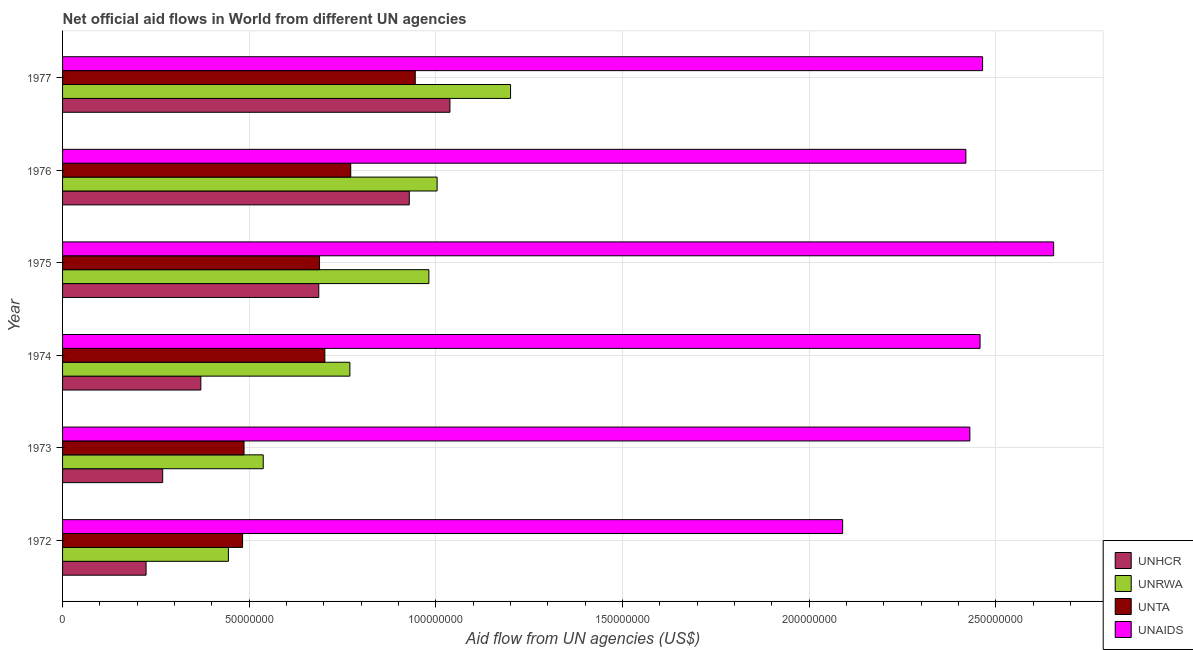How many different coloured bars are there?
Provide a short and direct response. 4. How many groups of bars are there?
Give a very brief answer. 6. Are the number of bars on each tick of the Y-axis equal?
Ensure brevity in your answer.  Yes. What is the label of the 2nd group of bars from the top?
Offer a very short reply. 1976. In how many cases, is the number of bars for a given year not equal to the number of legend labels?
Provide a succinct answer. 0. What is the amount of aid given by unaids in 1975?
Your answer should be very brief. 2.65e+08. Across all years, what is the maximum amount of aid given by unaids?
Make the answer very short. 2.65e+08. Across all years, what is the minimum amount of aid given by unrwa?
Provide a succinct answer. 4.44e+07. In which year was the amount of aid given by unaids maximum?
Ensure brevity in your answer.  1975. What is the total amount of aid given by unhcr in the graph?
Provide a succinct answer. 3.51e+08. What is the difference between the amount of aid given by unta in 1972 and that in 1976?
Make the answer very short. -2.90e+07. What is the difference between the amount of aid given by unrwa in 1972 and the amount of aid given by unaids in 1975?
Ensure brevity in your answer.  -2.21e+08. What is the average amount of aid given by unhcr per year?
Make the answer very short. 5.86e+07. In the year 1977, what is the difference between the amount of aid given by unrwa and amount of aid given by unaids?
Ensure brevity in your answer.  -1.26e+08. In how many years, is the amount of aid given by unta greater than 40000000 US$?
Provide a short and direct response. 6. What is the ratio of the amount of aid given by unhcr in 1973 to that in 1974?
Your answer should be compact. 0.72. What is the difference between the highest and the second highest amount of aid given by unrwa?
Offer a very short reply. 1.97e+07. What is the difference between the highest and the lowest amount of aid given by unhcr?
Provide a succinct answer. 8.14e+07. In how many years, is the amount of aid given by unhcr greater than the average amount of aid given by unhcr taken over all years?
Give a very brief answer. 3. What does the 2nd bar from the top in 1974 represents?
Provide a succinct answer. UNTA. What does the 3rd bar from the bottom in 1976 represents?
Ensure brevity in your answer.  UNTA. Is it the case that in every year, the sum of the amount of aid given by unhcr and amount of aid given by unrwa is greater than the amount of aid given by unta?
Provide a short and direct response. Yes. How many years are there in the graph?
Your answer should be very brief. 6. Does the graph contain grids?
Give a very brief answer. Yes. How many legend labels are there?
Make the answer very short. 4. How are the legend labels stacked?
Your response must be concise. Vertical. What is the title of the graph?
Provide a short and direct response. Net official aid flows in World from different UN agencies. Does "Manufacturing" appear as one of the legend labels in the graph?
Provide a short and direct response. No. What is the label or title of the X-axis?
Your answer should be compact. Aid flow from UN agencies (US$). What is the Aid flow from UN agencies (US$) of UNHCR in 1972?
Make the answer very short. 2.24e+07. What is the Aid flow from UN agencies (US$) of UNRWA in 1972?
Your response must be concise. 4.44e+07. What is the Aid flow from UN agencies (US$) in UNTA in 1972?
Provide a short and direct response. 4.82e+07. What is the Aid flow from UN agencies (US$) in UNAIDS in 1972?
Provide a succinct answer. 2.09e+08. What is the Aid flow from UN agencies (US$) in UNHCR in 1973?
Make the answer very short. 2.68e+07. What is the Aid flow from UN agencies (US$) in UNRWA in 1973?
Give a very brief answer. 5.38e+07. What is the Aid flow from UN agencies (US$) in UNTA in 1973?
Keep it short and to the point. 4.86e+07. What is the Aid flow from UN agencies (US$) in UNAIDS in 1973?
Your response must be concise. 2.43e+08. What is the Aid flow from UN agencies (US$) of UNHCR in 1974?
Your response must be concise. 3.70e+07. What is the Aid flow from UN agencies (US$) of UNRWA in 1974?
Offer a terse response. 7.70e+07. What is the Aid flow from UN agencies (US$) of UNTA in 1974?
Offer a terse response. 7.03e+07. What is the Aid flow from UN agencies (US$) of UNAIDS in 1974?
Your response must be concise. 2.46e+08. What is the Aid flow from UN agencies (US$) of UNHCR in 1975?
Keep it short and to the point. 6.86e+07. What is the Aid flow from UN agencies (US$) in UNRWA in 1975?
Give a very brief answer. 9.81e+07. What is the Aid flow from UN agencies (US$) in UNTA in 1975?
Your answer should be very brief. 6.88e+07. What is the Aid flow from UN agencies (US$) of UNAIDS in 1975?
Keep it short and to the point. 2.65e+08. What is the Aid flow from UN agencies (US$) in UNHCR in 1976?
Offer a very short reply. 9.29e+07. What is the Aid flow from UN agencies (US$) of UNRWA in 1976?
Provide a short and direct response. 1.00e+08. What is the Aid flow from UN agencies (US$) in UNTA in 1976?
Ensure brevity in your answer.  7.72e+07. What is the Aid flow from UN agencies (US$) in UNAIDS in 1976?
Your response must be concise. 2.42e+08. What is the Aid flow from UN agencies (US$) in UNHCR in 1977?
Ensure brevity in your answer.  1.04e+08. What is the Aid flow from UN agencies (US$) in UNRWA in 1977?
Provide a succinct answer. 1.20e+08. What is the Aid flow from UN agencies (US$) in UNTA in 1977?
Provide a succinct answer. 9.45e+07. What is the Aid flow from UN agencies (US$) of UNAIDS in 1977?
Give a very brief answer. 2.46e+08. Across all years, what is the maximum Aid flow from UN agencies (US$) of UNHCR?
Offer a very short reply. 1.04e+08. Across all years, what is the maximum Aid flow from UN agencies (US$) of UNRWA?
Your response must be concise. 1.20e+08. Across all years, what is the maximum Aid flow from UN agencies (US$) of UNTA?
Provide a short and direct response. 9.45e+07. Across all years, what is the maximum Aid flow from UN agencies (US$) in UNAIDS?
Make the answer very short. 2.65e+08. Across all years, what is the minimum Aid flow from UN agencies (US$) in UNHCR?
Offer a terse response. 2.24e+07. Across all years, what is the minimum Aid flow from UN agencies (US$) in UNRWA?
Your response must be concise. 4.44e+07. Across all years, what is the minimum Aid flow from UN agencies (US$) in UNTA?
Offer a very short reply. 4.82e+07. Across all years, what is the minimum Aid flow from UN agencies (US$) of UNAIDS?
Give a very brief answer. 2.09e+08. What is the total Aid flow from UN agencies (US$) of UNHCR in the graph?
Your answer should be very brief. 3.51e+08. What is the total Aid flow from UN agencies (US$) of UNRWA in the graph?
Your response must be concise. 4.94e+08. What is the total Aid flow from UN agencies (US$) in UNTA in the graph?
Keep it short and to the point. 4.08e+08. What is the total Aid flow from UN agencies (US$) in UNAIDS in the graph?
Ensure brevity in your answer.  1.45e+09. What is the difference between the Aid flow from UN agencies (US$) in UNHCR in 1972 and that in 1973?
Keep it short and to the point. -4.45e+06. What is the difference between the Aid flow from UN agencies (US$) of UNRWA in 1972 and that in 1973?
Provide a short and direct response. -9.33e+06. What is the difference between the Aid flow from UN agencies (US$) in UNTA in 1972 and that in 1973?
Your answer should be very brief. -3.90e+05. What is the difference between the Aid flow from UN agencies (US$) of UNAIDS in 1972 and that in 1973?
Offer a very short reply. -3.41e+07. What is the difference between the Aid flow from UN agencies (US$) in UNHCR in 1972 and that in 1974?
Give a very brief answer. -1.47e+07. What is the difference between the Aid flow from UN agencies (US$) in UNRWA in 1972 and that in 1974?
Give a very brief answer. -3.25e+07. What is the difference between the Aid flow from UN agencies (US$) in UNTA in 1972 and that in 1974?
Offer a terse response. -2.20e+07. What is the difference between the Aid flow from UN agencies (US$) in UNAIDS in 1972 and that in 1974?
Your answer should be very brief. -3.68e+07. What is the difference between the Aid flow from UN agencies (US$) in UNHCR in 1972 and that in 1975?
Offer a terse response. -4.63e+07. What is the difference between the Aid flow from UN agencies (US$) of UNRWA in 1972 and that in 1975?
Offer a terse response. -5.37e+07. What is the difference between the Aid flow from UN agencies (US$) of UNTA in 1972 and that in 1975?
Your response must be concise. -2.06e+07. What is the difference between the Aid flow from UN agencies (US$) of UNAIDS in 1972 and that in 1975?
Your response must be concise. -5.65e+07. What is the difference between the Aid flow from UN agencies (US$) in UNHCR in 1972 and that in 1976?
Provide a short and direct response. -7.05e+07. What is the difference between the Aid flow from UN agencies (US$) in UNRWA in 1972 and that in 1976?
Offer a very short reply. -5.59e+07. What is the difference between the Aid flow from UN agencies (US$) in UNTA in 1972 and that in 1976?
Provide a short and direct response. -2.90e+07. What is the difference between the Aid flow from UN agencies (US$) in UNAIDS in 1972 and that in 1976?
Make the answer very short. -3.30e+07. What is the difference between the Aid flow from UN agencies (US$) in UNHCR in 1972 and that in 1977?
Make the answer very short. -8.14e+07. What is the difference between the Aid flow from UN agencies (US$) in UNRWA in 1972 and that in 1977?
Give a very brief answer. -7.56e+07. What is the difference between the Aid flow from UN agencies (US$) in UNTA in 1972 and that in 1977?
Your answer should be very brief. -4.62e+07. What is the difference between the Aid flow from UN agencies (US$) in UNAIDS in 1972 and that in 1977?
Give a very brief answer. -3.75e+07. What is the difference between the Aid flow from UN agencies (US$) in UNHCR in 1973 and that in 1974?
Your answer should be very brief. -1.02e+07. What is the difference between the Aid flow from UN agencies (US$) of UNRWA in 1973 and that in 1974?
Provide a short and direct response. -2.32e+07. What is the difference between the Aid flow from UN agencies (US$) in UNTA in 1973 and that in 1974?
Keep it short and to the point. -2.16e+07. What is the difference between the Aid flow from UN agencies (US$) in UNAIDS in 1973 and that in 1974?
Give a very brief answer. -2.73e+06. What is the difference between the Aid flow from UN agencies (US$) in UNHCR in 1973 and that in 1975?
Keep it short and to the point. -4.18e+07. What is the difference between the Aid flow from UN agencies (US$) of UNRWA in 1973 and that in 1975?
Provide a succinct answer. -4.44e+07. What is the difference between the Aid flow from UN agencies (US$) of UNTA in 1973 and that in 1975?
Provide a short and direct response. -2.02e+07. What is the difference between the Aid flow from UN agencies (US$) of UNAIDS in 1973 and that in 1975?
Make the answer very short. -2.24e+07. What is the difference between the Aid flow from UN agencies (US$) of UNHCR in 1973 and that in 1976?
Provide a short and direct response. -6.60e+07. What is the difference between the Aid flow from UN agencies (US$) of UNRWA in 1973 and that in 1976?
Provide a short and direct response. -4.66e+07. What is the difference between the Aid flow from UN agencies (US$) of UNTA in 1973 and that in 1976?
Provide a short and direct response. -2.86e+07. What is the difference between the Aid flow from UN agencies (US$) in UNAIDS in 1973 and that in 1976?
Provide a succinct answer. 1.06e+06. What is the difference between the Aid flow from UN agencies (US$) of UNHCR in 1973 and that in 1977?
Provide a short and direct response. -7.69e+07. What is the difference between the Aid flow from UN agencies (US$) in UNRWA in 1973 and that in 1977?
Offer a very short reply. -6.62e+07. What is the difference between the Aid flow from UN agencies (US$) of UNTA in 1973 and that in 1977?
Your response must be concise. -4.59e+07. What is the difference between the Aid flow from UN agencies (US$) of UNAIDS in 1973 and that in 1977?
Provide a short and direct response. -3.41e+06. What is the difference between the Aid flow from UN agencies (US$) of UNHCR in 1974 and that in 1975?
Your answer should be compact. -3.16e+07. What is the difference between the Aid flow from UN agencies (US$) in UNRWA in 1974 and that in 1975?
Ensure brevity in your answer.  -2.12e+07. What is the difference between the Aid flow from UN agencies (US$) of UNTA in 1974 and that in 1975?
Ensure brevity in your answer.  1.43e+06. What is the difference between the Aid flow from UN agencies (US$) of UNAIDS in 1974 and that in 1975?
Make the answer very short. -1.97e+07. What is the difference between the Aid flow from UN agencies (US$) in UNHCR in 1974 and that in 1976?
Your answer should be compact. -5.58e+07. What is the difference between the Aid flow from UN agencies (US$) of UNRWA in 1974 and that in 1976?
Offer a terse response. -2.34e+07. What is the difference between the Aid flow from UN agencies (US$) of UNTA in 1974 and that in 1976?
Ensure brevity in your answer.  -6.93e+06. What is the difference between the Aid flow from UN agencies (US$) in UNAIDS in 1974 and that in 1976?
Offer a terse response. 3.79e+06. What is the difference between the Aid flow from UN agencies (US$) of UNHCR in 1974 and that in 1977?
Offer a very short reply. -6.67e+07. What is the difference between the Aid flow from UN agencies (US$) of UNRWA in 1974 and that in 1977?
Ensure brevity in your answer.  -4.30e+07. What is the difference between the Aid flow from UN agencies (US$) of UNTA in 1974 and that in 1977?
Your response must be concise. -2.42e+07. What is the difference between the Aid flow from UN agencies (US$) of UNAIDS in 1974 and that in 1977?
Offer a terse response. -6.80e+05. What is the difference between the Aid flow from UN agencies (US$) in UNHCR in 1975 and that in 1976?
Make the answer very short. -2.42e+07. What is the difference between the Aid flow from UN agencies (US$) of UNRWA in 1975 and that in 1976?
Offer a terse response. -2.20e+06. What is the difference between the Aid flow from UN agencies (US$) in UNTA in 1975 and that in 1976?
Provide a succinct answer. -8.36e+06. What is the difference between the Aid flow from UN agencies (US$) in UNAIDS in 1975 and that in 1976?
Offer a very short reply. 2.35e+07. What is the difference between the Aid flow from UN agencies (US$) in UNHCR in 1975 and that in 1977?
Provide a short and direct response. -3.51e+07. What is the difference between the Aid flow from UN agencies (US$) of UNRWA in 1975 and that in 1977?
Make the answer very short. -2.19e+07. What is the difference between the Aid flow from UN agencies (US$) of UNTA in 1975 and that in 1977?
Your answer should be very brief. -2.56e+07. What is the difference between the Aid flow from UN agencies (US$) in UNAIDS in 1975 and that in 1977?
Give a very brief answer. 1.90e+07. What is the difference between the Aid flow from UN agencies (US$) in UNHCR in 1976 and that in 1977?
Provide a succinct answer. -1.09e+07. What is the difference between the Aid flow from UN agencies (US$) of UNRWA in 1976 and that in 1977?
Your answer should be very brief. -1.97e+07. What is the difference between the Aid flow from UN agencies (US$) of UNTA in 1976 and that in 1977?
Offer a terse response. -1.73e+07. What is the difference between the Aid flow from UN agencies (US$) of UNAIDS in 1976 and that in 1977?
Offer a terse response. -4.47e+06. What is the difference between the Aid flow from UN agencies (US$) in UNHCR in 1972 and the Aid flow from UN agencies (US$) in UNRWA in 1973?
Keep it short and to the point. -3.14e+07. What is the difference between the Aid flow from UN agencies (US$) of UNHCR in 1972 and the Aid flow from UN agencies (US$) of UNTA in 1973?
Provide a short and direct response. -2.62e+07. What is the difference between the Aid flow from UN agencies (US$) in UNHCR in 1972 and the Aid flow from UN agencies (US$) in UNAIDS in 1973?
Give a very brief answer. -2.21e+08. What is the difference between the Aid flow from UN agencies (US$) in UNRWA in 1972 and the Aid flow from UN agencies (US$) in UNTA in 1973?
Keep it short and to the point. -4.19e+06. What is the difference between the Aid flow from UN agencies (US$) of UNRWA in 1972 and the Aid flow from UN agencies (US$) of UNAIDS in 1973?
Offer a terse response. -1.99e+08. What is the difference between the Aid flow from UN agencies (US$) of UNTA in 1972 and the Aid flow from UN agencies (US$) of UNAIDS in 1973?
Offer a very short reply. -1.95e+08. What is the difference between the Aid flow from UN agencies (US$) of UNHCR in 1972 and the Aid flow from UN agencies (US$) of UNRWA in 1974?
Provide a short and direct response. -5.46e+07. What is the difference between the Aid flow from UN agencies (US$) of UNHCR in 1972 and the Aid flow from UN agencies (US$) of UNTA in 1974?
Your response must be concise. -4.79e+07. What is the difference between the Aid flow from UN agencies (US$) in UNHCR in 1972 and the Aid flow from UN agencies (US$) in UNAIDS in 1974?
Make the answer very short. -2.23e+08. What is the difference between the Aid flow from UN agencies (US$) in UNRWA in 1972 and the Aid flow from UN agencies (US$) in UNTA in 1974?
Your answer should be compact. -2.58e+07. What is the difference between the Aid flow from UN agencies (US$) in UNRWA in 1972 and the Aid flow from UN agencies (US$) in UNAIDS in 1974?
Offer a terse response. -2.01e+08. What is the difference between the Aid flow from UN agencies (US$) of UNTA in 1972 and the Aid flow from UN agencies (US$) of UNAIDS in 1974?
Make the answer very short. -1.98e+08. What is the difference between the Aid flow from UN agencies (US$) in UNHCR in 1972 and the Aid flow from UN agencies (US$) in UNRWA in 1975?
Offer a terse response. -7.58e+07. What is the difference between the Aid flow from UN agencies (US$) of UNHCR in 1972 and the Aid flow from UN agencies (US$) of UNTA in 1975?
Give a very brief answer. -4.65e+07. What is the difference between the Aid flow from UN agencies (US$) in UNHCR in 1972 and the Aid flow from UN agencies (US$) in UNAIDS in 1975?
Provide a succinct answer. -2.43e+08. What is the difference between the Aid flow from UN agencies (US$) of UNRWA in 1972 and the Aid flow from UN agencies (US$) of UNTA in 1975?
Give a very brief answer. -2.44e+07. What is the difference between the Aid flow from UN agencies (US$) in UNRWA in 1972 and the Aid flow from UN agencies (US$) in UNAIDS in 1975?
Offer a terse response. -2.21e+08. What is the difference between the Aid flow from UN agencies (US$) in UNTA in 1972 and the Aid flow from UN agencies (US$) in UNAIDS in 1975?
Your answer should be compact. -2.17e+08. What is the difference between the Aid flow from UN agencies (US$) in UNHCR in 1972 and the Aid flow from UN agencies (US$) in UNRWA in 1976?
Offer a terse response. -7.80e+07. What is the difference between the Aid flow from UN agencies (US$) of UNHCR in 1972 and the Aid flow from UN agencies (US$) of UNTA in 1976?
Provide a short and direct response. -5.48e+07. What is the difference between the Aid flow from UN agencies (US$) in UNHCR in 1972 and the Aid flow from UN agencies (US$) in UNAIDS in 1976?
Your answer should be compact. -2.20e+08. What is the difference between the Aid flow from UN agencies (US$) of UNRWA in 1972 and the Aid flow from UN agencies (US$) of UNTA in 1976?
Keep it short and to the point. -3.28e+07. What is the difference between the Aid flow from UN agencies (US$) in UNRWA in 1972 and the Aid flow from UN agencies (US$) in UNAIDS in 1976?
Offer a very short reply. -1.98e+08. What is the difference between the Aid flow from UN agencies (US$) of UNTA in 1972 and the Aid flow from UN agencies (US$) of UNAIDS in 1976?
Your answer should be very brief. -1.94e+08. What is the difference between the Aid flow from UN agencies (US$) in UNHCR in 1972 and the Aid flow from UN agencies (US$) in UNRWA in 1977?
Make the answer very short. -9.76e+07. What is the difference between the Aid flow from UN agencies (US$) in UNHCR in 1972 and the Aid flow from UN agencies (US$) in UNTA in 1977?
Your answer should be compact. -7.21e+07. What is the difference between the Aid flow from UN agencies (US$) in UNHCR in 1972 and the Aid flow from UN agencies (US$) in UNAIDS in 1977?
Keep it short and to the point. -2.24e+08. What is the difference between the Aid flow from UN agencies (US$) of UNRWA in 1972 and the Aid flow from UN agencies (US$) of UNTA in 1977?
Your response must be concise. -5.00e+07. What is the difference between the Aid flow from UN agencies (US$) of UNRWA in 1972 and the Aid flow from UN agencies (US$) of UNAIDS in 1977?
Your response must be concise. -2.02e+08. What is the difference between the Aid flow from UN agencies (US$) in UNTA in 1972 and the Aid flow from UN agencies (US$) in UNAIDS in 1977?
Ensure brevity in your answer.  -1.98e+08. What is the difference between the Aid flow from UN agencies (US$) in UNHCR in 1973 and the Aid flow from UN agencies (US$) in UNRWA in 1974?
Provide a succinct answer. -5.01e+07. What is the difference between the Aid flow from UN agencies (US$) in UNHCR in 1973 and the Aid flow from UN agencies (US$) in UNTA in 1974?
Ensure brevity in your answer.  -4.34e+07. What is the difference between the Aid flow from UN agencies (US$) in UNHCR in 1973 and the Aid flow from UN agencies (US$) in UNAIDS in 1974?
Provide a succinct answer. -2.19e+08. What is the difference between the Aid flow from UN agencies (US$) of UNRWA in 1973 and the Aid flow from UN agencies (US$) of UNTA in 1974?
Ensure brevity in your answer.  -1.65e+07. What is the difference between the Aid flow from UN agencies (US$) of UNRWA in 1973 and the Aid flow from UN agencies (US$) of UNAIDS in 1974?
Offer a terse response. -1.92e+08. What is the difference between the Aid flow from UN agencies (US$) of UNTA in 1973 and the Aid flow from UN agencies (US$) of UNAIDS in 1974?
Make the answer very short. -1.97e+08. What is the difference between the Aid flow from UN agencies (US$) in UNHCR in 1973 and the Aid flow from UN agencies (US$) in UNRWA in 1975?
Your response must be concise. -7.13e+07. What is the difference between the Aid flow from UN agencies (US$) of UNHCR in 1973 and the Aid flow from UN agencies (US$) of UNTA in 1975?
Your answer should be very brief. -4.20e+07. What is the difference between the Aid flow from UN agencies (US$) of UNHCR in 1973 and the Aid flow from UN agencies (US$) of UNAIDS in 1975?
Your answer should be compact. -2.39e+08. What is the difference between the Aid flow from UN agencies (US$) of UNRWA in 1973 and the Aid flow from UN agencies (US$) of UNTA in 1975?
Your answer should be very brief. -1.51e+07. What is the difference between the Aid flow from UN agencies (US$) of UNRWA in 1973 and the Aid flow from UN agencies (US$) of UNAIDS in 1975?
Provide a short and direct response. -2.12e+08. What is the difference between the Aid flow from UN agencies (US$) in UNTA in 1973 and the Aid flow from UN agencies (US$) in UNAIDS in 1975?
Provide a short and direct response. -2.17e+08. What is the difference between the Aid flow from UN agencies (US$) of UNHCR in 1973 and the Aid flow from UN agencies (US$) of UNRWA in 1976?
Offer a very short reply. -7.35e+07. What is the difference between the Aid flow from UN agencies (US$) in UNHCR in 1973 and the Aid flow from UN agencies (US$) in UNTA in 1976?
Keep it short and to the point. -5.04e+07. What is the difference between the Aid flow from UN agencies (US$) of UNHCR in 1973 and the Aid flow from UN agencies (US$) of UNAIDS in 1976?
Provide a succinct answer. -2.15e+08. What is the difference between the Aid flow from UN agencies (US$) of UNRWA in 1973 and the Aid flow from UN agencies (US$) of UNTA in 1976?
Make the answer very short. -2.34e+07. What is the difference between the Aid flow from UN agencies (US$) in UNRWA in 1973 and the Aid flow from UN agencies (US$) in UNAIDS in 1976?
Offer a very short reply. -1.88e+08. What is the difference between the Aid flow from UN agencies (US$) in UNTA in 1973 and the Aid flow from UN agencies (US$) in UNAIDS in 1976?
Provide a succinct answer. -1.93e+08. What is the difference between the Aid flow from UN agencies (US$) of UNHCR in 1973 and the Aid flow from UN agencies (US$) of UNRWA in 1977?
Give a very brief answer. -9.32e+07. What is the difference between the Aid flow from UN agencies (US$) in UNHCR in 1973 and the Aid flow from UN agencies (US$) in UNTA in 1977?
Offer a very short reply. -6.76e+07. What is the difference between the Aid flow from UN agencies (US$) in UNHCR in 1973 and the Aid flow from UN agencies (US$) in UNAIDS in 1977?
Provide a succinct answer. -2.20e+08. What is the difference between the Aid flow from UN agencies (US$) of UNRWA in 1973 and the Aid flow from UN agencies (US$) of UNTA in 1977?
Your answer should be very brief. -4.07e+07. What is the difference between the Aid flow from UN agencies (US$) of UNRWA in 1973 and the Aid flow from UN agencies (US$) of UNAIDS in 1977?
Ensure brevity in your answer.  -1.93e+08. What is the difference between the Aid flow from UN agencies (US$) of UNTA in 1973 and the Aid flow from UN agencies (US$) of UNAIDS in 1977?
Ensure brevity in your answer.  -1.98e+08. What is the difference between the Aid flow from UN agencies (US$) of UNHCR in 1974 and the Aid flow from UN agencies (US$) of UNRWA in 1975?
Offer a very short reply. -6.11e+07. What is the difference between the Aid flow from UN agencies (US$) in UNHCR in 1974 and the Aid flow from UN agencies (US$) in UNTA in 1975?
Provide a succinct answer. -3.18e+07. What is the difference between the Aid flow from UN agencies (US$) in UNHCR in 1974 and the Aid flow from UN agencies (US$) in UNAIDS in 1975?
Ensure brevity in your answer.  -2.28e+08. What is the difference between the Aid flow from UN agencies (US$) of UNRWA in 1974 and the Aid flow from UN agencies (US$) of UNTA in 1975?
Provide a short and direct response. 8.13e+06. What is the difference between the Aid flow from UN agencies (US$) of UNRWA in 1974 and the Aid flow from UN agencies (US$) of UNAIDS in 1975?
Offer a very short reply. -1.89e+08. What is the difference between the Aid flow from UN agencies (US$) in UNTA in 1974 and the Aid flow from UN agencies (US$) in UNAIDS in 1975?
Ensure brevity in your answer.  -1.95e+08. What is the difference between the Aid flow from UN agencies (US$) of UNHCR in 1974 and the Aid flow from UN agencies (US$) of UNRWA in 1976?
Your answer should be compact. -6.33e+07. What is the difference between the Aid flow from UN agencies (US$) in UNHCR in 1974 and the Aid flow from UN agencies (US$) in UNTA in 1976?
Your answer should be very brief. -4.02e+07. What is the difference between the Aid flow from UN agencies (US$) in UNHCR in 1974 and the Aid flow from UN agencies (US$) in UNAIDS in 1976?
Offer a terse response. -2.05e+08. What is the difference between the Aid flow from UN agencies (US$) in UNRWA in 1974 and the Aid flow from UN agencies (US$) in UNAIDS in 1976?
Your answer should be very brief. -1.65e+08. What is the difference between the Aid flow from UN agencies (US$) of UNTA in 1974 and the Aid flow from UN agencies (US$) of UNAIDS in 1976?
Provide a succinct answer. -1.72e+08. What is the difference between the Aid flow from UN agencies (US$) in UNHCR in 1974 and the Aid flow from UN agencies (US$) in UNRWA in 1977?
Provide a succinct answer. -8.30e+07. What is the difference between the Aid flow from UN agencies (US$) of UNHCR in 1974 and the Aid flow from UN agencies (US$) of UNTA in 1977?
Make the answer very short. -5.74e+07. What is the difference between the Aid flow from UN agencies (US$) in UNHCR in 1974 and the Aid flow from UN agencies (US$) in UNAIDS in 1977?
Keep it short and to the point. -2.09e+08. What is the difference between the Aid flow from UN agencies (US$) of UNRWA in 1974 and the Aid flow from UN agencies (US$) of UNTA in 1977?
Offer a terse response. -1.75e+07. What is the difference between the Aid flow from UN agencies (US$) in UNRWA in 1974 and the Aid flow from UN agencies (US$) in UNAIDS in 1977?
Your answer should be compact. -1.69e+08. What is the difference between the Aid flow from UN agencies (US$) of UNTA in 1974 and the Aid flow from UN agencies (US$) of UNAIDS in 1977?
Your response must be concise. -1.76e+08. What is the difference between the Aid flow from UN agencies (US$) in UNHCR in 1975 and the Aid flow from UN agencies (US$) in UNRWA in 1976?
Make the answer very short. -3.17e+07. What is the difference between the Aid flow from UN agencies (US$) of UNHCR in 1975 and the Aid flow from UN agencies (US$) of UNTA in 1976?
Offer a very short reply. -8.56e+06. What is the difference between the Aid flow from UN agencies (US$) of UNHCR in 1975 and the Aid flow from UN agencies (US$) of UNAIDS in 1976?
Offer a terse response. -1.73e+08. What is the difference between the Aid flow from UN agencies (US$) of UNRWA in 1975 and the Aid flow from UN agencies (US$) of UNTA in 1976?
Offer a very short reply. 2.09e+07. What is the difference between the Aid flow from UN agencies (US$) of UNRWA in 1975 and the Aid flow from UN agencies (US$) of UNAIDS in 1976?
Offer a very short reply. -1.44e+08. What is the difference between the Aid flow from UN agencies (US$) of UNTA in 1975 and the Aid flow from UN agencies (US$) of UNAIDS in 1976?
Ensure brevity in your answer.  -1.73e+08. What is the difference between the Aid flow from UN agencies (US$) of UNHCR in 1975 and the Aid flow from UN agencies (US$) of UNRWA in 1977?
Make the answer very short. -5.14e+07. What is the difference between the Aid flow from UN agencies (US$) of UNHCR in 1975 and the Aid flow from UN agencies (US$) of UNTA in 1977?
Ensure brevity in your answer.  -2.58e+07. What is the difference between the Aid flow from UN agencies (US$) in UNHCR in 1975 and the Aid flow from UN agencies (US$) in UNAIDS in 1977?
Your answer should be very brief. -1.78e+08. What is the difference between the Aid flow from UN agencies (US$) in UNRWA in 1975 and the Aid flow from UN agencies (US$) in UNTA in 1977?
Offer a very short reply. 3.65e+06. What is the difference between the Aid flow from UN agencies (US$) of UNRWA in 1975 and the Aid flow from UN agencies (US$) of UNAIDS in 1977?
Provide a short and direct response. -1.48e+08. What is the difference between the Aid flow from UN agencies (US$) of UNTA in 1975 and the Aid flow from UN agencies (US$) of UNAIDS in 1977?
Keep it short and to the point. -1.78e+08. What is the difference between the Aid flow from UN agencies (US$) of UNHCR in 1976 and the Aid flow from UN agencies (US$) of UNRWA in 1977?
Provide a succinct answer. -2.71e+07. What is the difference between the Aid flow from UN agencies (US$) of UNHCR in 1976 and the Aid flow from UN agencies (US$) of UNTA in 1977?
Offer a terse response. -1.60e+06. What is the difference between the Aid flow from UN agencies (US$) of UNHCR in 1976 and the Aid flow from UN agencies (US$) of UNAIDS in 1977?
Provide a short and direct response. -1.54e+08. What is the difference between the Aid flow from UN agencies (US$) of UNRWA in 1976 and the Aid flow from UN agencies (US$) of UNTA in 1977?
Provide a succinct answer. 5.85e+06. What is the difference between the Aid flow from UN agencies (US$) of UNRWA in 1976 and the Aid flow from UN agencies (US$) of UNAIDS in 1977?
Give a very brief answer. -1.46e+08. What is the difference between the Aid flow from UN agencies (US$) of UNTA in 1976 and the Aid flow from UN agencies (US$) of UNAIDS in 1977?
Your answer should be compact. -1.69e+08. What is the average Aid flow from UN agencies (US$) of UNHCR per year?
Provide a succinct answer. 5.86e+07. What is the average Aid flow from UN agencies (US$) of UNRWA per year?
Offer a terse response. 8.23e+07. What is the average Aid flow from UN agencies (US$) of UNTA per year?
Your answer should be compact. 6.79e+07. What is the average Aid flow from UN agencies (US$) in UNAIDS per year?
Make the answer very short. 2.42e+08. In the year 1972, what is the difference between the Aid flow from UN agencies (US$) in UNHCR and Aid flow from UN agencies (US$) in UNRWA?
Give a very brief answer. -2.20e+07. In the year 1972, what is the difference between the Aid flow from UN agencies (US$) of UNHCR and Aid flow from UN agencies (US$) of UNTA?
Offer a very short reply. -2.58e+07. In the year 1972, what is the difference between the Aid flow from UN agencies (US$) of UNHCR and Aid flow from UN agencies (US$) of UNAIDS?
Your response must be concise. -1.87e+08. In the year 1972, what is the difference between the Aid flow from UN agencies (US$) in UNRWA and Aid flow from UN agencies (US$) in UNTA?
Ensure brevity in your answer.  -3.80e+06. In the year 1972, what is the difference between the Aid flow from UN agencies (US$) in UNRWA and Aid flow from UN agencies (US$) in UNAIDS?
Give a very brief answer. -1.65e+08. In the year 1972, what is the difference between the Aid flow from UN agencies (US$) in UNTA and Aid flow from UN agencies (US$) in UNAIDS?
Your response must be concise. -1.61e+08. In the year 1973, what is the difference between the Aid flow from UN agencies (US$) in UNHCR and Aid flow from UN agencies (US$) in UNRWA?
Make the answer very short. -2.69e+07. In the year 1973, what is the difference between the Aid flow from UN agencies (US$) of UNHCR and Aid flow from UN agencies (US$) of UNTA?
Your answer should be compact. -2.18e+07. In the year 1973, what is the difference between the Aid flow from UN agencies (US$) in UNHCR and Aid flow from UN agencies (US$) in UNAIDS?
Offer a terse response. -2.16e+08. In the year 1973, what is the difference between the Aid flow from UN agencies (US$) in UNRWA and Aid flow from UN agencies (US$) in UNTA?
Give a very brief answer. 5.14e+06. In the year 1973, what is the difference between the Aid flow from UN agencies (US$) of UNRWA and Aid flow from UN agencies (US$) of UNAIDS?
Provide a succinct answer. -1.89e+08. In the year 1973, what is the difference between the Aid flow from UN agencies (US$) of UNTA and Aid flow from UN agencies (US$) of UNAIDS?
Give a very brief answer. -1.94e+08. In the year 1974, what is the difference between the Aid flow from UN agencies (US$) in UNHCR and Aid flow from UN agencies (US$) in UNRWA?
Make the answer very short. -3.99e+07. In the year 1974, what is the difference between the Aid flow from UN agencies (US$) in UNHCR and Aid flow from UN agencies (US$) in UNTA?
Provide a short and direct response. -3.32e+07. In the year 1974, what is the difference between the Aid flow from UN agencies (US$) of UNHCR and Aid flow from UN agencies (US$) of UNAIDS?
Provide a succinct answer. -2.09e+08. In the year 1974, what is the difference between the Aid flow from UN agencies (US$) of UNRWA and Aid flow from UN agencies (US$) of UNTA?
Your answer should be compact. 6.70e+06. In the year 1974, what is the difference between the Aid flow from UN agencies (US$) of UNRWA and Aid flow from UN agencies (US$) of UNAIDS?
Your answer should be very brief. -1.69e+08. In the year 1974, what is the difference between the Aid flow from UN agencies (US$) of UNTA and Aid flow from UN agencies (US$) of UNAIDS?
Keep it short and to the point. -1.76e+08. In the year 1975, what is the difference between the Aid flow from UN agencies (US$) in UNHCR and Aid flow from UN agencies (US$) in UNRWA?
Provide a short and direct response. -2.95e+07. In the year 1975, what is the difference between the Aid flow from UN agencies (US$) of UNHCR and Aid flow from UN agencies (US$) of UNAIDS?
Your answer should be very brief. -1.97e+08. In the year 1975, what is the difference between the Aid flow from UN agencies (US$) of UNRWA and Aid flow from UN agencies (US$) of UNTA?
Your answer should be compact. 2.93e+07. In the year 1975, what is the difference between the Aid flow from UN agencies (US$) in UNRWA and Aid flow from UN agencies (US$) in UNAIDS?
Offer a very short reply. -1.67e+08. In the year 1975, what is the difference between the Aid flow from UN agencies (US$) of UNTA and Aid flow from UN agencies (US$) of UNAIDS?
Ensure brevity in your answer.  -1.97e+08. In the year 1976, what is the difference between the Aid flow from UN agencies (US$) of UNHCR and Aid flow from UN agencies (US$) of UNRWA?
Your answer should be compact. -7.45e+06. In the year 1976, what is the difference between the Aid flow from UN agencies (US$) in UNHCR and Aid flow from UN agencies (US$) in UNTA?
Give a very brief answer. 1.57e+07. In the year 1976, what is the difference between the Aid flow from UN agencies (US$) in UNHCR and Aid flow from UN agencies (US$) in UNAIDS?
Make the answer very short. -1.49e+08. In the year 1976, what is the difference between the Aid flow from UN agencies (US$) in UNRWA and Aid flow from UN agencies (US$) in UNTA?
Your response must be concise. 2.31e+07. In the year 1976, what is the difference between the Aid flow from UN agencies (US$) in UNRWA and Aid flow from UN agencies (US$) in UNAIDS?
Your answer should be very brief. -1.42e+08. In the year 1976, what is the difference between the Aid flow from UN agencies (US$) in UNTA and Aid flow from UN agencies (US$) in UNAIDS?
Ensure brevity in your answer.  -1.65e+08. In the year 1977, what is the difference between the Aid flow from UN agencies (US$) in UNHCR and Aid flow from UN agencies (US$) in UNRWA?
Make the answer very short. -1.62e+07. In the year 1977, what is the difference between the Aid flow from UN agencies (US$) in UNHCR and Aid flow from UN agencies (US$) in UNTA?
Provide a succinct answer. 9.29e+06. In the year 1977, what is the difference between the Aid flow from UN agencies (US$) in UNHCR and Aid flow from UN agencies (US$) in UNAIDS?
Give a very brief answer. -1.43e+08. In the year 1977, what is the difference between the Aid flow from UN agencies (US$) of UNRWA and Aid flow from UN agencies (US$) of UNTA?
Ensure brevity in your answer.  2.55e+07. In the year 1977, what is the difference between the Aid flow from UN agencies (US$) in UNRWA and Aid flow from UN agencies (US$) in UNAIDS?
Give a very brief answer. -1.26e+08. In the year 1977, what is the difference between the Aid flow from UN agencies (US$) in UNTA and Aid flow from UN agencies (US$) in UNAIDS?
Give a very brief answer. -1.52e+08. What is the ratio of the Aid flow from UN agencies (US$) of UNHCR in 1972 to that in 1973?
Your answer should be compact. 0.83. What is the ratio of the Aid flow from UN agencies (US$) in UNRWA in 1972 to that in 1973?
Your response must be concise. 0.83. What is the ratio of the Aid flow from UN agencies (US$) in UNTA in 1972 to that in 1973?
Your answer should be very brief. 0.99. What is the ratio of the Aid flow from UN agencies (US$) in UNAIDS in 1972 to that in 1973?
Your response must be concise. 0.86. What is the ratio of the Aid flow from UN agencies (US$) of UNHCR in 1972 to that in 1974?
Provide a succinct answer. 0.6. What is the ratio of the Aid flow from UN agencies (US$) in UNRWA in 1972 to that in 1974?
Make the answer very short. 0.58. What is the ratio of the Aid flow from UN agencies (US$) in UNTA in 1972 to that in 1974?
Your response must be concise. 0.69. What is the ratio of the Aid flow from UN agencies (US$) of UNAIDS in 1972 to that in 1974?
Provide a short and direct response. 0.85. What is the ratio of the Aid flow from UN agencies (US$) in UNHCR in 1972 to that in 1975?
Give a very brief answer. 0.33. What is the ratio of the Aid flow from UN agencies (US$) of UNRWA in 1972 to that in 1975?
Offer a very short reply. 0.45. What is the ratio of the Aid flow from UN agencies (US$) in UNTA in 1972 to that in 1975?
Offer a very short reply. 0.7. What is the ratio of the Aid flow from UN agencies (US$) in UNAIDS in 1972 to that in 1975?
Offer a terse response. 0.79. What is the ratio of the Aid flow from UN agencies (US$) of UNHCR in 1972 to that in 1976?
Ensure brevity in your answer.  0.24. What is the ratio of the Aid flow from UN agencies (US$) in UNRWA in 1972 to that in 1976?
Provide a succinct answer. 0.44. What is the ratio of the Aid flow from UN agencies (US$) in UNTA in 1972 to that in 1976?
Ensure brevity in your answer.  0.62. What is the ratio of the Aid flow from UN agencies (US$) in UNAIDS in 1972 to that in 1976?
Your answer should be compact. 0.86. What is the ratio of the Aid flow from UN agencies (US$) of UNHCR in 1972 to that in 1977?
Keep it short and to the point. 0.22. What is the ratio of the Aid flow from UN agencies (US$) of UNRWA in 1972 to that in 1977?
Offer a terse response. 0.37. What is the ratio of the Aid flow from UN agencies (US$) of UNTA in 1972 to that in 1977?
Provide a succinct answer. 0.51. What is the ratio of the Aid flow from UN agencies (US$) in UNAIDS in 1972 to that in 1977?
Your response must be concise. 0.85. What is the ratio of the Aid flow from UN agencies (US$) of UNHCR in 1973 to that in 1974?
Your answer should be compact. 0.72. What is the ratio of the Aid flow from UN agencies (US$) of UNRWA in 1973 to that in 1974?
Your answer should be very brief. 0.7. What is the ratio of the Aid flow from UN agencies (US$) of UNTA in 1973 to that in 1974?
Your response must be concise. 0.69. What is the ratio of the Aid flow from UN agencies (US$) of UNAIDS in 1973 to that in 1974?
Offer a very short reply. 0.99. What is the ratio of the Aid flow from UN agencies (US$) in UNHCR in 1973 to that in 1975?
Provide a succinct answer. 0.39. What is the ratio of the Aid flow from UN agencies (US$) in UNRWA in 1973 to that in 1975?
Offer a very short reply. 0.55. What is the ratio of the Aid flow from UN agencies (US$) in UNTA in 1973 to that in 1975?
Your answer should be very brief. 0.71. What is the ratio of the Aid flow from UN agencies (US$) in UNAIDS in 1973 to that in 1975?
Ensure brevity in your answer.  0.92. What is the ratio of the Aid flow from UN agencies (US$) of UNHCR in 1973 to that in 1976?
Your answer should be very brief. 0.29. What is the ratio of the Aid flow from UN agencies (US$) of UNRWA in 1973 to that in 1976?
Provide a short and direct response. 0.54. What is the ratio of the Aid flow from UN agencies (US$) of UNTA in 1973 to that in 1976?
Ensure brevity in your answer.  0.63. What is the ratio of the Aid flow from UN agencies (US$) of UNAIDS in 1973 to that in 1976?
Offer a terse response. 1. What is the ratio of the Aid flow from UN agencies (US$) in UNHCR in 1973 to that in 1977?
Offer a terse response. 0.26. What is the ratio of the Aid flow from UN agencies (US$) in UNRWA in 1973 to that in 1977?
Keep it short and to the point. 0.45. What is the ratio of the Aid flow from UN agencies (US$) in UNTA in 1973 to that in 1977?
Provide a short and direct response. 0.51. What is the ratio of the Aid flow from UN agencies (US$) in UNAIDS in 1973 to that in 1977?
Your response must be concise. 0.99. What is the ratio of the Aid flow from UN agencies (US$) of UNHCR in 1974 to that in 1975?
Make the answer very short. 0.54. What is the ratio of the Aid flow from UN agencies (US$) of UNRWA in 1974 to that in 1975?
Ensure brevity in your answer.  0.78. What is the ratio of the Aid flow from UN agencies (US$) of UNTA in 1974 to that in 1975?
Offer a very short reply. 1.02. What is the ratio of the Aid flow from UN agencies (US$) of UNAIDS in 1974 to that in 1975?
Make the answer very short. 0.93. What is the ratio of the Aid flow from UN agencies (US$) in UNHCR in 1974 to that in 1976?
Provide a short and direct response. 0.4. What is the ratio of the Aid flow from UN agencies (US$) in UNRWA in 1974 to that in 1976?
Offer a terse response. 0.77. What is the ratio of the Aid flow from UN agencies (US$) in UNTA in 1974 to that in 1976?
Your answer should be compact. 0.91. What is the ratio of the Aid flow from UN agencies (US$) of UNAIDS in 1974 to that in 1976?
Your response must be concise. 1.02. What is the ratio of the Aid flow from UN agencies (US$) of UNHCR in 1974 to that in 1977?
Offer a very short reply. 0.36. What is the ratio of the Aid flow from UN agencies (US$) in UNRWA in 1974 to that in 1977?
Your answer should be compact. 0.64. What is the ratio of the Aid flow from UN agencies (US$) of UNTA in 1974 to that in 1977?
Make the answer very short. 0.74. What is the ratio of the Aid flow from UN agencies (US$) in UNHCR in 1975 to that in 1976?
Provide a succinct answer. 0.74. What is the ratio of the Aid flow from UN agencies (US$) of UNRWA in 1975 to that in 1976?
Offer a terse response. 0.98. What is the ratio of the Aid flow from UN agencies (US$) in UNTA in 1975 to that in 1976?
Ensure brevity in your answer.  0.89. What is the ratio of the Aid flow from UN agencies (US$) in UNAIDS in 1975 to that in 1976?
Give a very brief answer. 1.1. What is the ratio of the Aid flow from UN agencies (US$) in UNHCR in 1975 to that in 1977?
Give a very brief answer. 0.66. What is the ratio of the Aid flow from UN agencies (US$) in UNRWA in 1975 to that in 1977?
Keep it short and to the point. 0.82. What is the ratio of the Aid flow from UN agencies (US$) in UNTA in 1975 to that in 1977?
Offer a terse response. 0.73. What is the ratio of the Aid flow from UN agencies (US$) of UNAIDS in 1975 to that in 1977?
Offer a terse response. 1.08. What is the ratio of the Aid flow from UN agencies (US$) in UNHCR in 1976 to that in 1977?
Your response must be concise. 0.9. What is the ratio of the Aid flow from UN agencies (US$) in UNRWA in 1976 to that in 1977?
Offer a terse response. 0.84. What is the ratio of the Aid flow from UN agencies (US$) in UNTA in 1976 to that in 1977?
Offer a terse response. 0.82. What is the ratio of the Aid flow from UN agencies (US$) in UNAIDS in 1976 to that in 1977?
Your response must be concise. 0.98. What is the difference between the highest and the second highest Aid flow from UN agencies (US$) of UNHCR?
Keep it short and to the point. 1.09e+07. What is the difference between the highest and the second highest Aid flow from UN agencies (US$) of UNRWA?
Ensure brevity in your answer.  1.97e+07. What is the difference between the highest and the second highest Aid flow from UN agencies (US$) of UNTA?
Provide a short and direct response. 1.73e+07. What is the difference between the highest and the second highest Aid flow from UN agencies (US$) in UNAIDS?
Provide a succinct answer. 1.90e+07. What is the difference between the highest and the lowest Aid flow from UN agencies (US$) of UNHCR?
Ensure brevity in your answer.  8.14e+07. What is the difference between the highest and the lowest Aid flow from UN agencies (US$) of UNRWA?
Provide a short and direct response. 7.56e+07. What is the difference between the highest and the lowest Aid flow from UN agencies (US$) of UNTA?
Ensure brevity in your answer.  4.62e+07. What is the difference between the highest and the lowest Aid flow from UN agencies (US$) of UNAIDS?
Your response must be concise. 5.65e+07. 